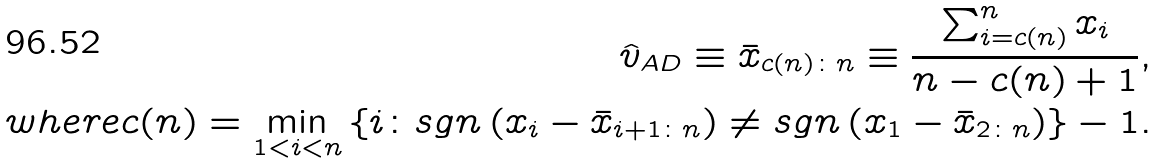Convert formula to latex. <formula><loc_0><loc_0><loc_500><loc_500>\hat { v } _ { A D } \equiv \bar { x } _ { c ( n ) \colon n } \equiv \frac { \sum _ { i = c ( n ) } ^ { n } x _ { i } } { n - c ( n ) + 1 } , \\ w h e r e c ( n ) = \min _ { 1 < i < n } \left \{ i \colon s g n \left ( x _ { i } - \bar { x } _ { i + 1 \colon n } \right ) \neq s g n \left ( x _ { 1 } - \bar { x } _ { 2 \colon n } \right ) \right \} - 1 .</formula> 